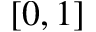<formula> <loc_0><loc_0><loc_500><loc_500>[ 0 , 1 ]</formula> 